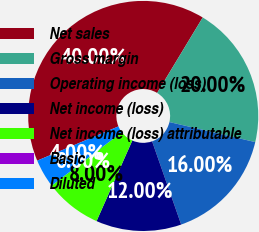Convert chart. <chart><loc_0><loc_0><loc_500><loc_500><pie_chart><fcel>Net sales<fcel>Gross margin<fcel>Operating income (loss)<fcel>Net income (loss)<fcel>Net income (loss) attributable<fcel>Basic<fcel>Diluted<nl><fcel>40.0%<fcel>20.0%<fcel>16.0%<fcel>12.0%<fcel>8.0%<fcel>0.0%<fcel>4.0%<nl></chart> 